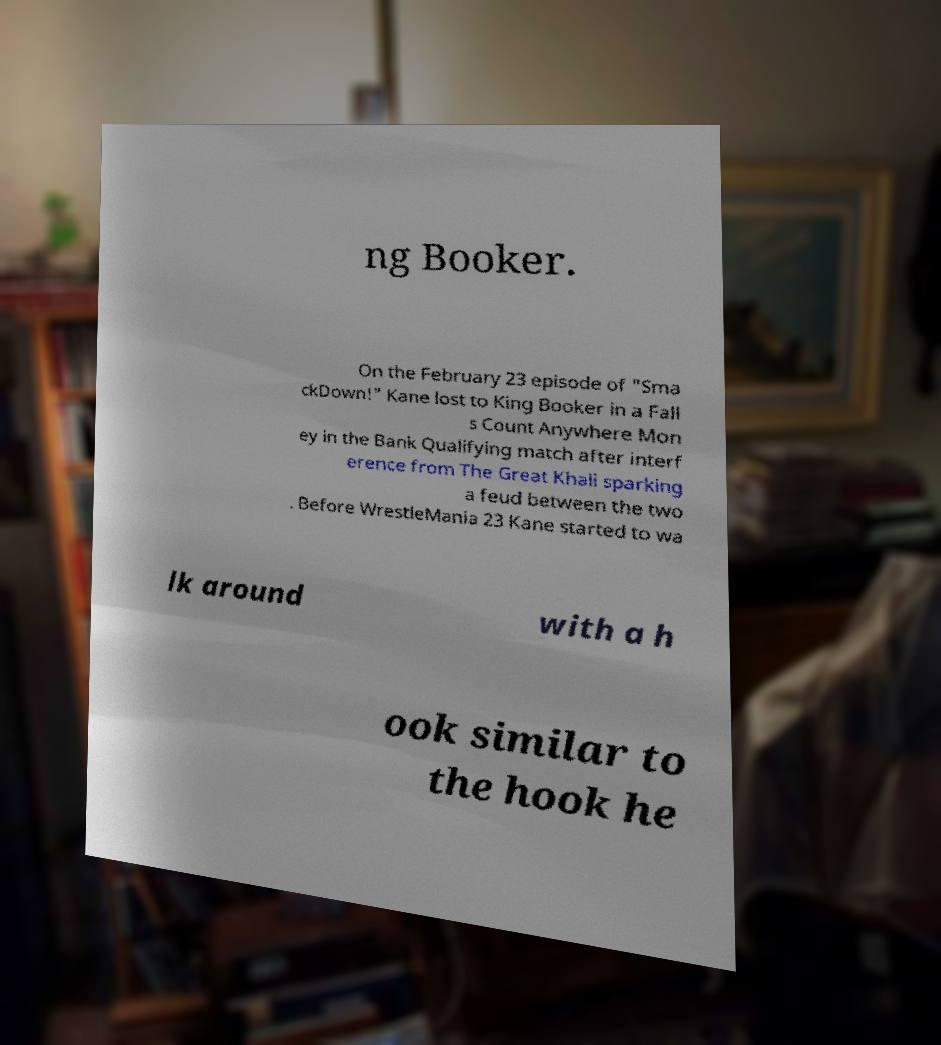Could you assist in decoding the text presented in this image and type it out clearly? ng Booker. On the February 23 episode of "Sma ckDown!" Kane lost to King Booker in a Fall s Count Anywhere Mon ey in the Bank Qualifying match after interf erence from The Great Khali sparking a feud between the two . Before WrestleMania 23 Kane started to wa lk around with a h ook similar to the hook he 